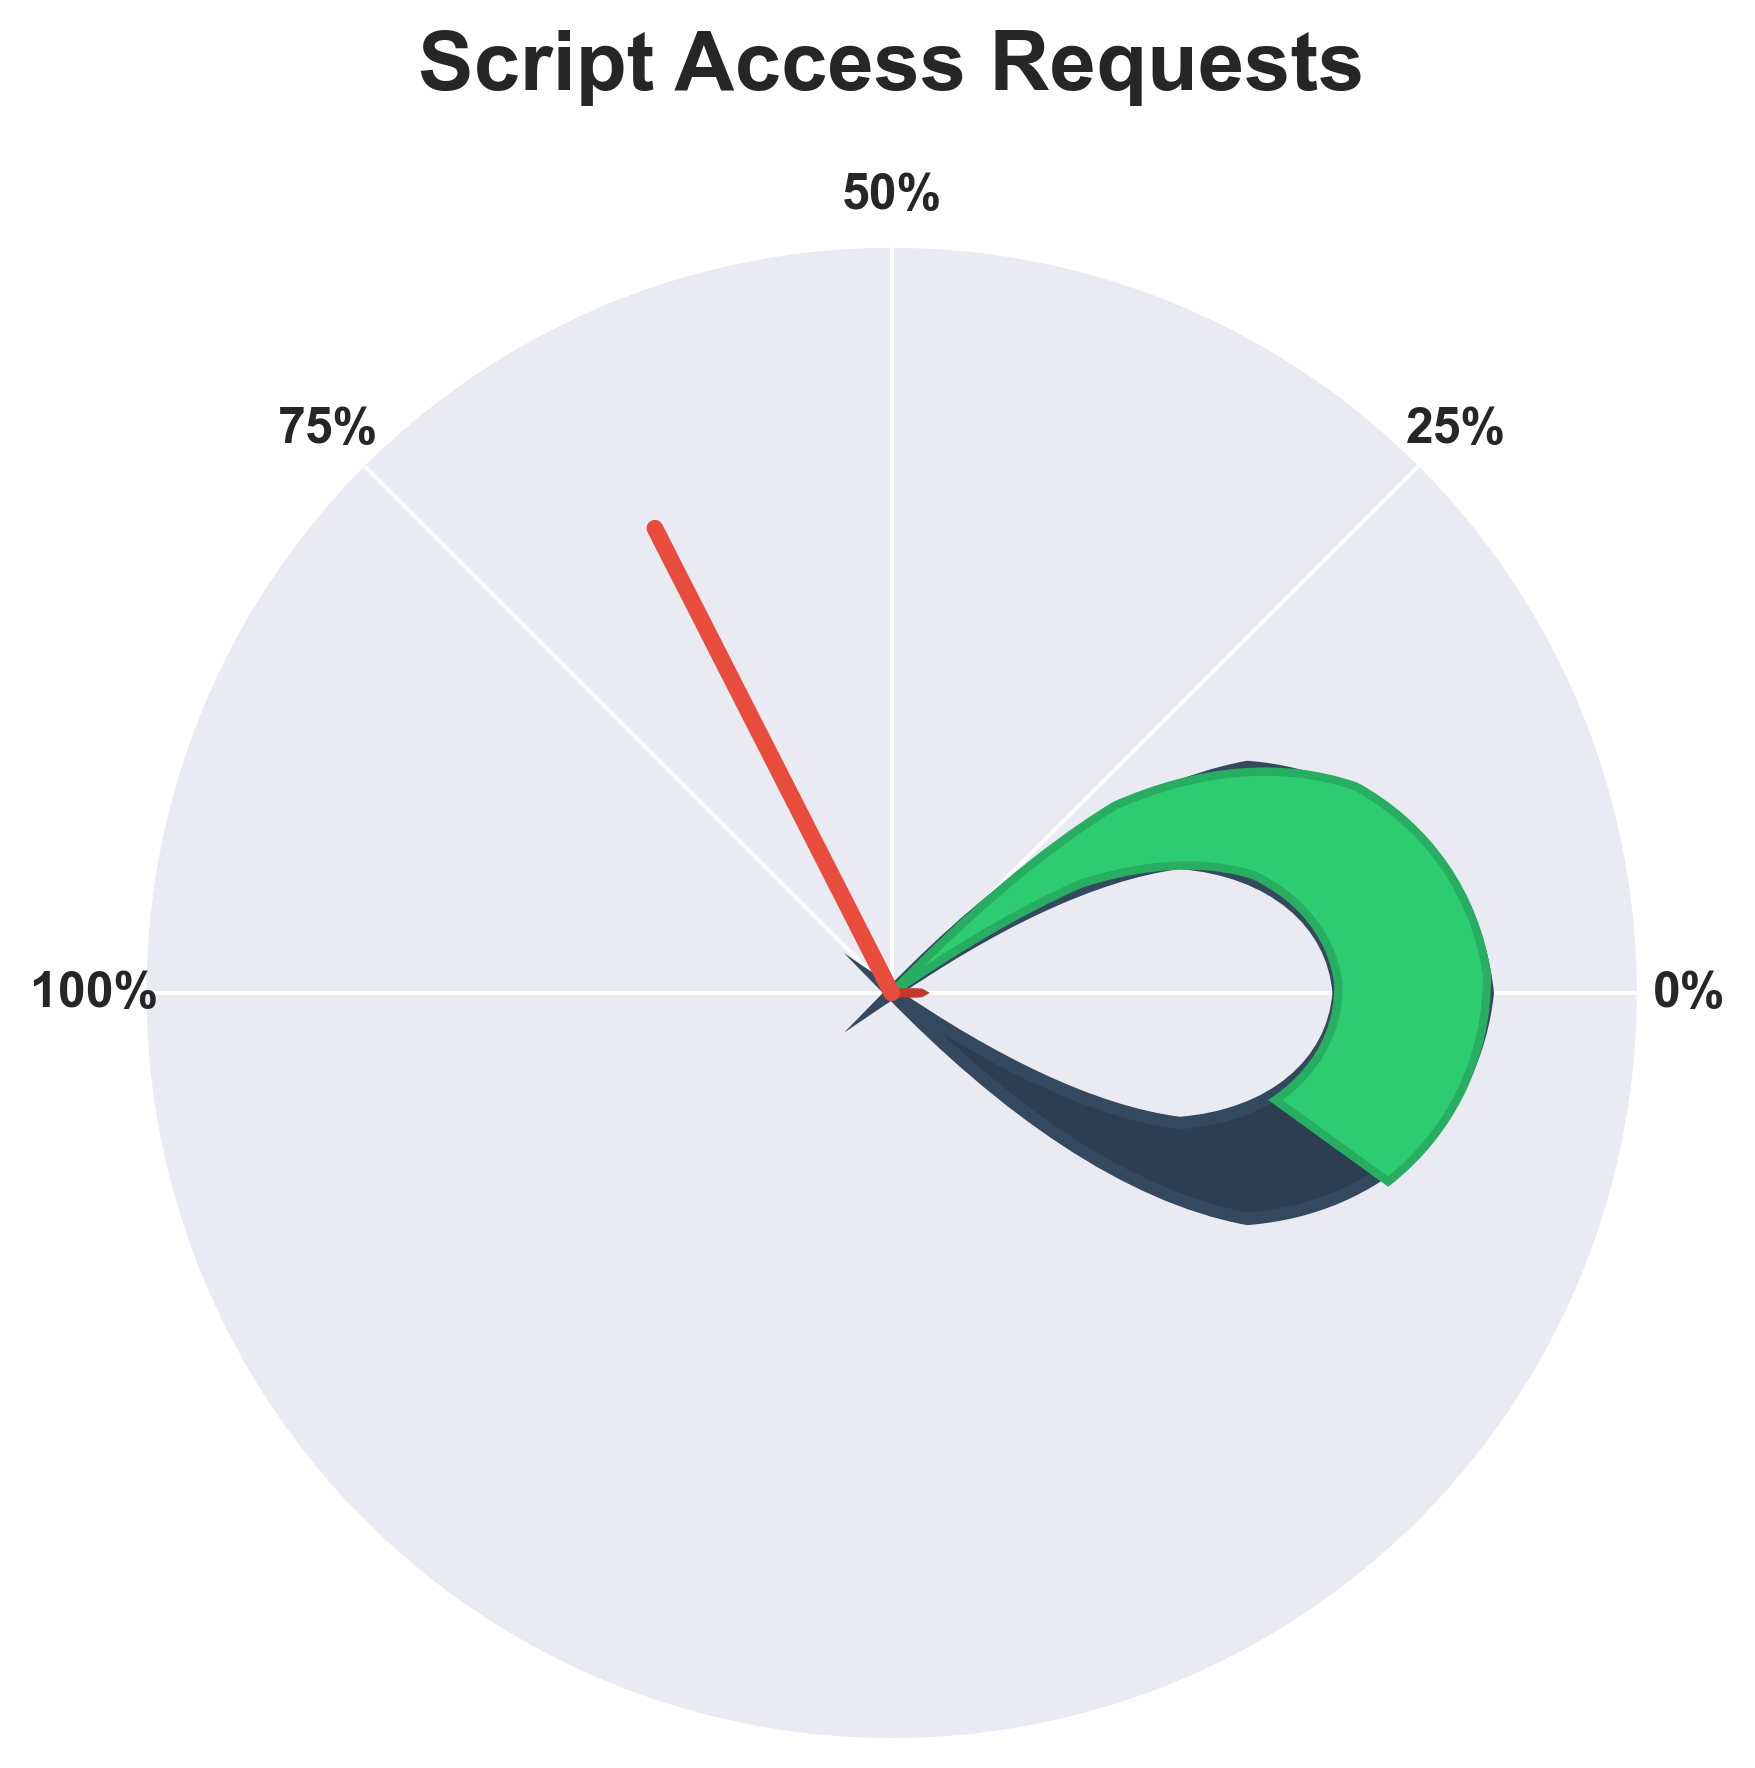How many percent of script access requests are approved? The gauge chart indicates the percentage of approved script access requests. The figure prominently shows "65%" in green near the approved section.
Answer: 65% What is the percentage of script access requests that were denied? The gauge chart has a red section labeled "Denied: 35%", indicating the percentage of denied requests.
Answer: 35% What is the title of the gauge chart? The title is prominently displayed at the top of the gauge chart and reads "Script Access Requests."
Answer: Script Access Requests Which category had a higher percentage: approved or denied? The green portion of the gauge chart reaches 65%, while the red portion reaches 35%, indicating a higher percentage of approved requests.
Answer: Approved What color represents the denied script access requests in the chart? The denied script access requests are visually represented by the red section of the gauge chart.
Answer: Red What color is used to depict approved script access requests on the gauge? The approved script access requests are depicted in green on the gauge chart.
Answer: Green Where is the needle pointing in the chart? The needle is pointing toward the approved portion, at the 65% mark of the gauge chart.
Answer: 65% How would you calculate the total percentage of all script access requests shown in the chart? The gauge chart divides the requests into approved and denied, representing the whole, so you sum these percentages: 65% (Approved) + 35% (Denied) = 100%.
Answer: 100% If the approved requests were to increase by 10%, what would the new approved percentage be? Starting with 65% approved, if we increase it by 10%, it becomes 65% + 10% = 75%.
Answer: 75% What specific figure type is used to represent the data on script access requests? The chart uses a gauge type that features a half-circle with colored segments and a needle to display the percentages.
Answer: Gauge Chart 